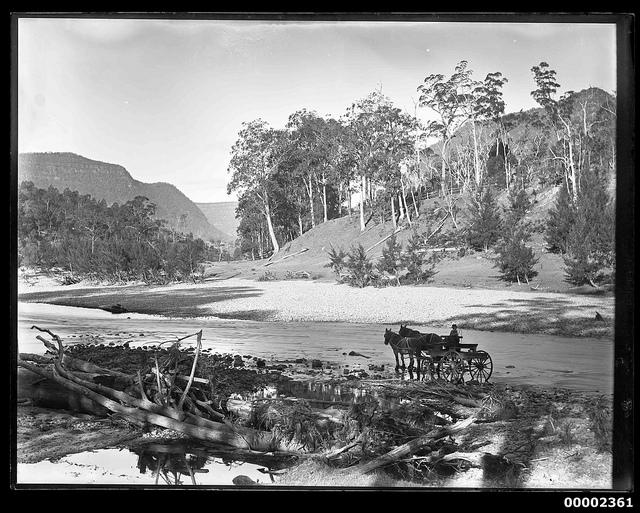What animals are in this photo?
Write a very short answer. Horses. Are there any trees in this photo?
Write a very short answer. Yes. According to the card, what is it too cold for?
Keep it brief. Swimming. Is this a color photo?
Be succinct. No. What is this person doing in the water?
Keep it brief. Riding. 